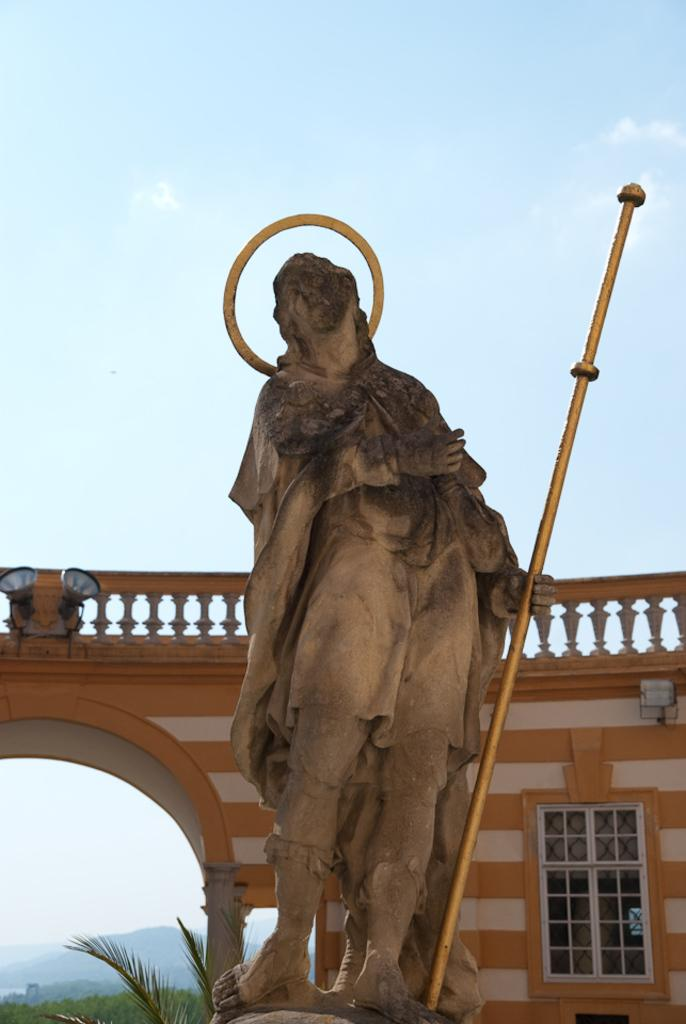What is the main subject in the image? There is a statue in the image. What other objects can be seen in the image? There is a pole, a wall, a railing, a window, a grill, and lights visible in the background of the image. What is the color of the sky in the image? The sky is visible in the background of the image. What type of vegetation is on the left side of the image? There are trees on the left side of the image. What is the hill on the left side of the image? There is a hill on the left side of the image. What type of net can be seen hanging from the statue in the image? There is no net present in the image; it only features a statue, pole, wall, railing, window, grill, lights, sky, trees, and a hill. 